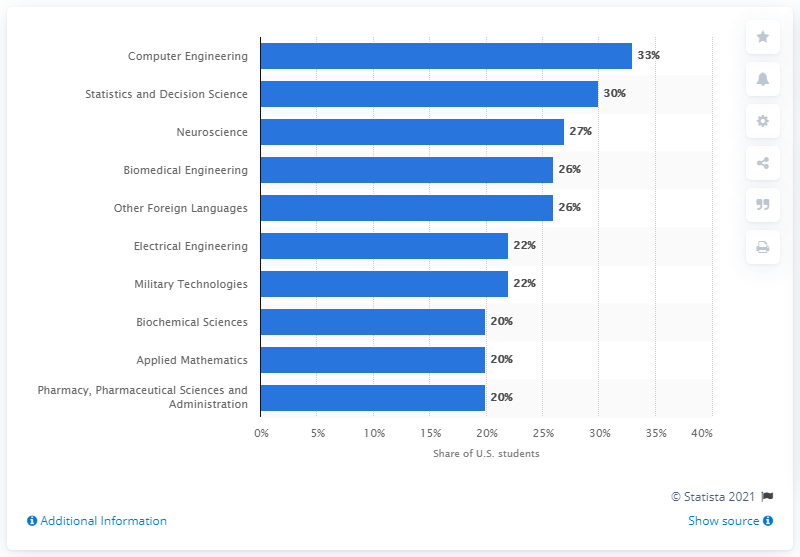Give some essential details in this illustration. According to information provided, approximately 30% of Asian students participated in statistics and decision science. 